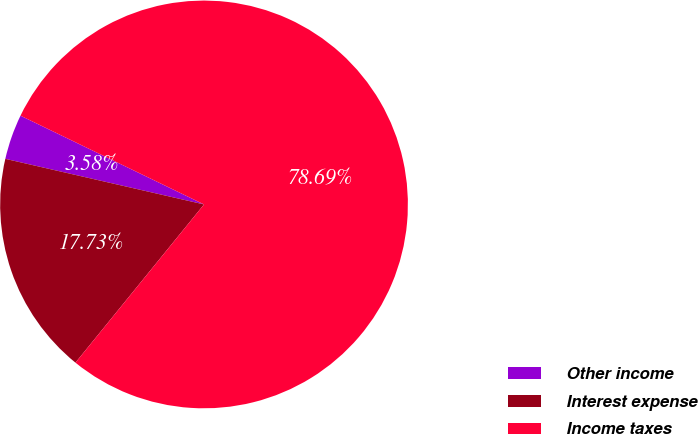Convert chart. <chart><loc_0><loc_0><loc_500><loc_500><pie_chart><fcel>Other income<fcel>Interest expense<fcel>Income taxes<nl><fcel>3.58%<fcel>17.73%<fcel>78.69%<nl></chart> 